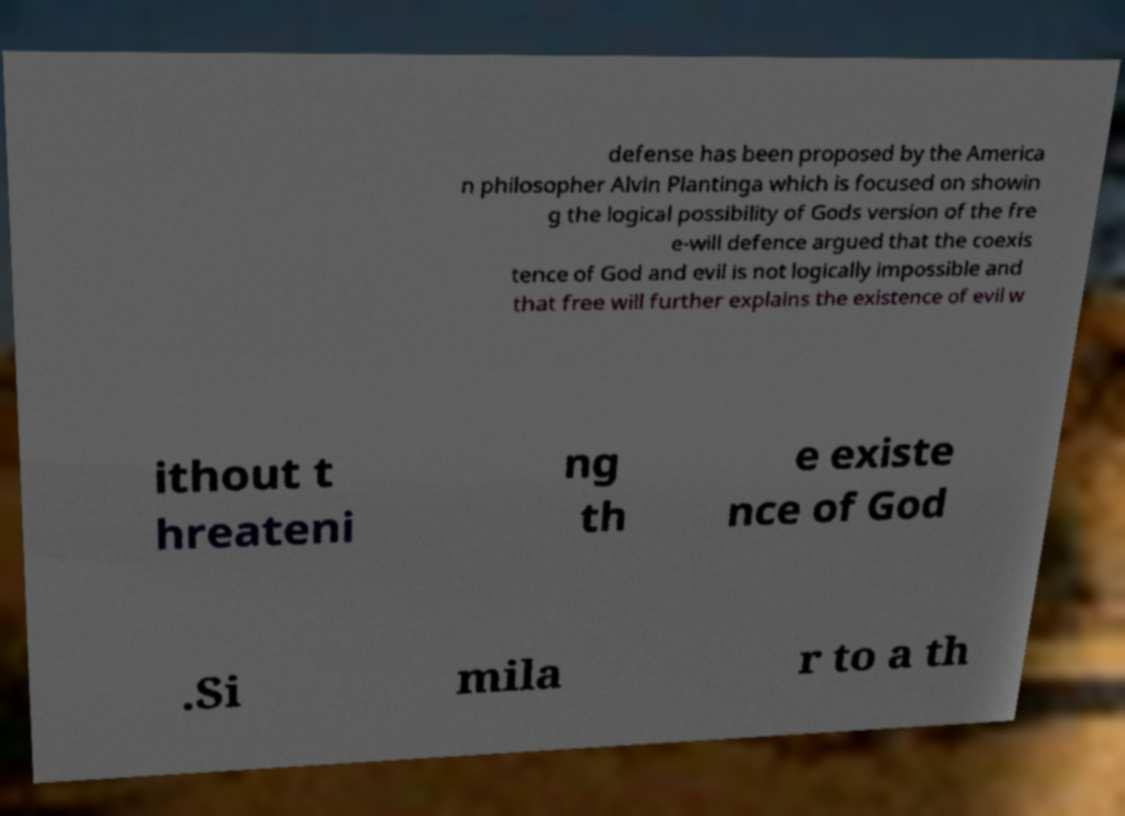Could you assist in decoding the text presented in this image and type it out clearly? defense has been proposed by the America n philosopher Alvin Plantinga which is focused on showin g the logical possibility of Gods version of the fre e-will defence argued that the coexis tence of God and evil is not logically impossible and that free will further explains the existence of evil w ithout t hreateni ng th e existe nce of God .Si mila r to a th 